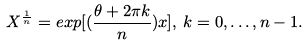Convert formula to latex. <formula><loc_0><loc_0><loc_500><loc_500>X ^ { \frac { 1 } { n } } = e x p [ ( \frac { \theta + 2 \pi k } { n } ) x ] , \, k = 0 , \dots , n - 1 .</formula> 